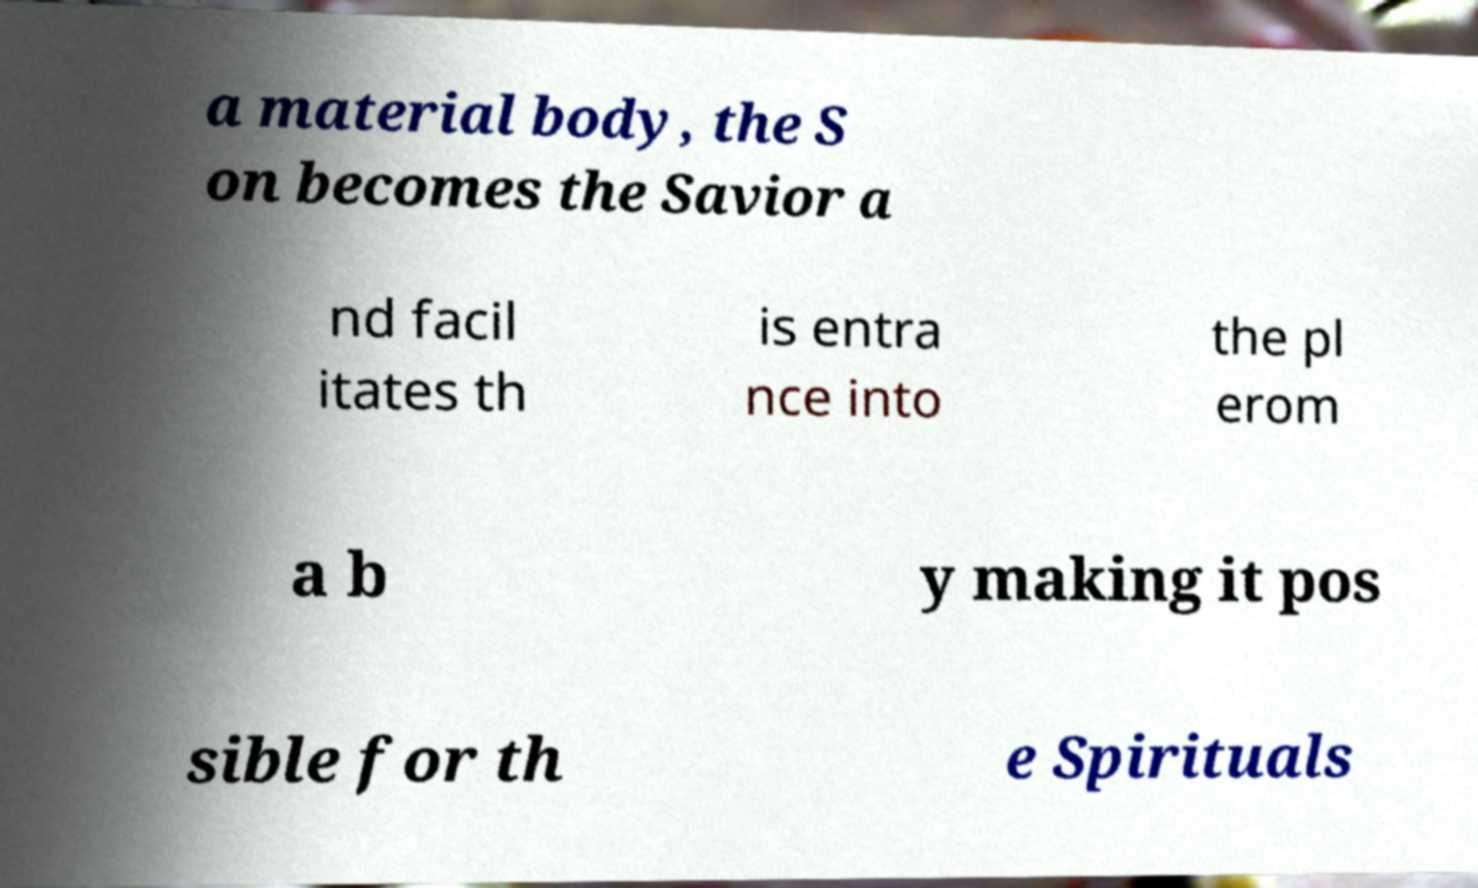What messages or text are displayed in this image? I need them in a readable, typed format. a material body, the S on becomes the Savior a nd facil itates th is entra nce into the pl erom a b y making it pos sible for th e Spirituals 